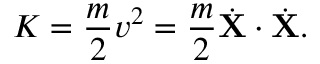<formula> <loc_0><loc_0><loc_500><loc_500>K = { \frac { m } { 2 } } v ^ { 2 } = { \frac { m } { 2 } } { \dot { X } } \cdot { \dot { X } } .</formula> 